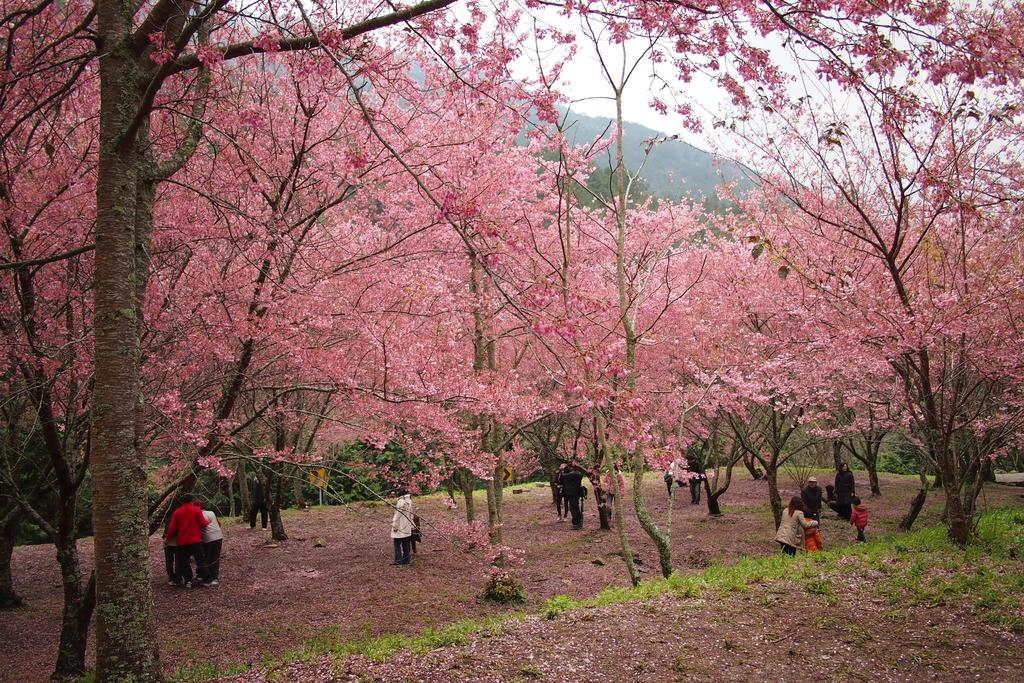What type of terrain is visible in the image? The ground with grass is visible in the image. What type of vegetation can be seen in the image? Plants and trees are present in the image. What part of the plants can be seen in the image? Leaves are visible in the image. What type of natural landform is present in the image? Mountains are present in the image. What part of the environment is visible in the image? The sky is visible in the image. What word is being spoken by the dust in the image? There is no dust or spoken word present in the image. 